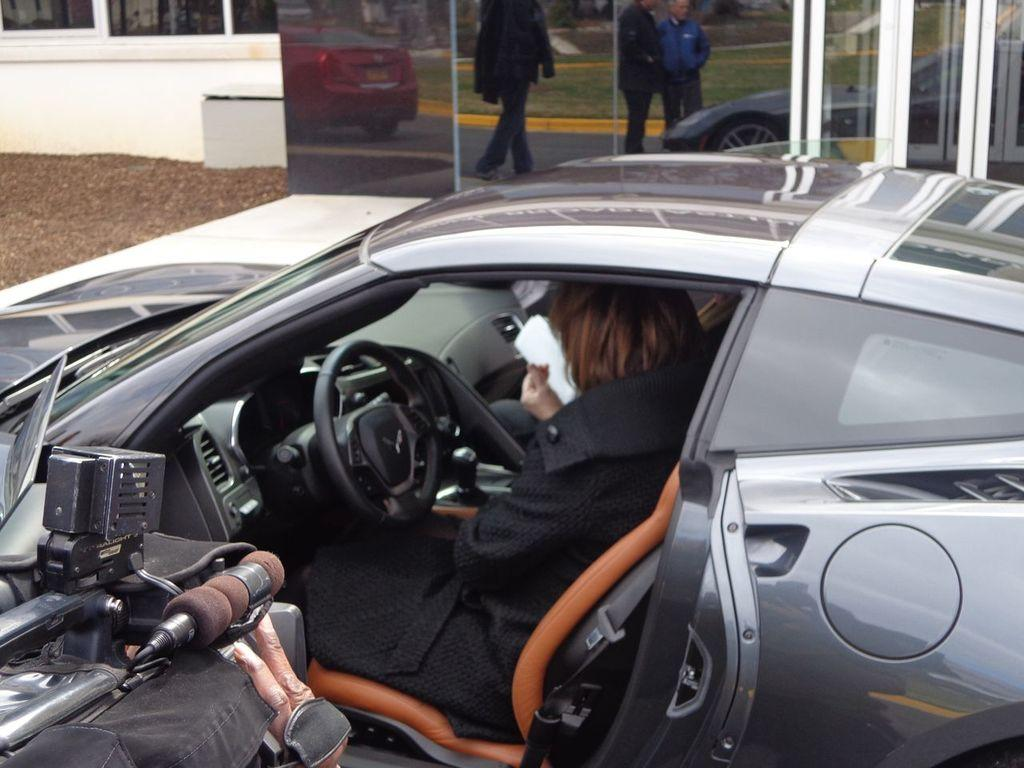What is the main subject of the image? There is a car in the image. Who or what is inside the car? A woman is sitting inside the car. Can you describe any other objects in the image? There is a camera on the left side of the image. How many horses can be seen in the image? There are no horses present in the image. What type of watch is the woman wearing in the image? The image does not show the woman wearing a watch, so it cannot be determined from the image. 